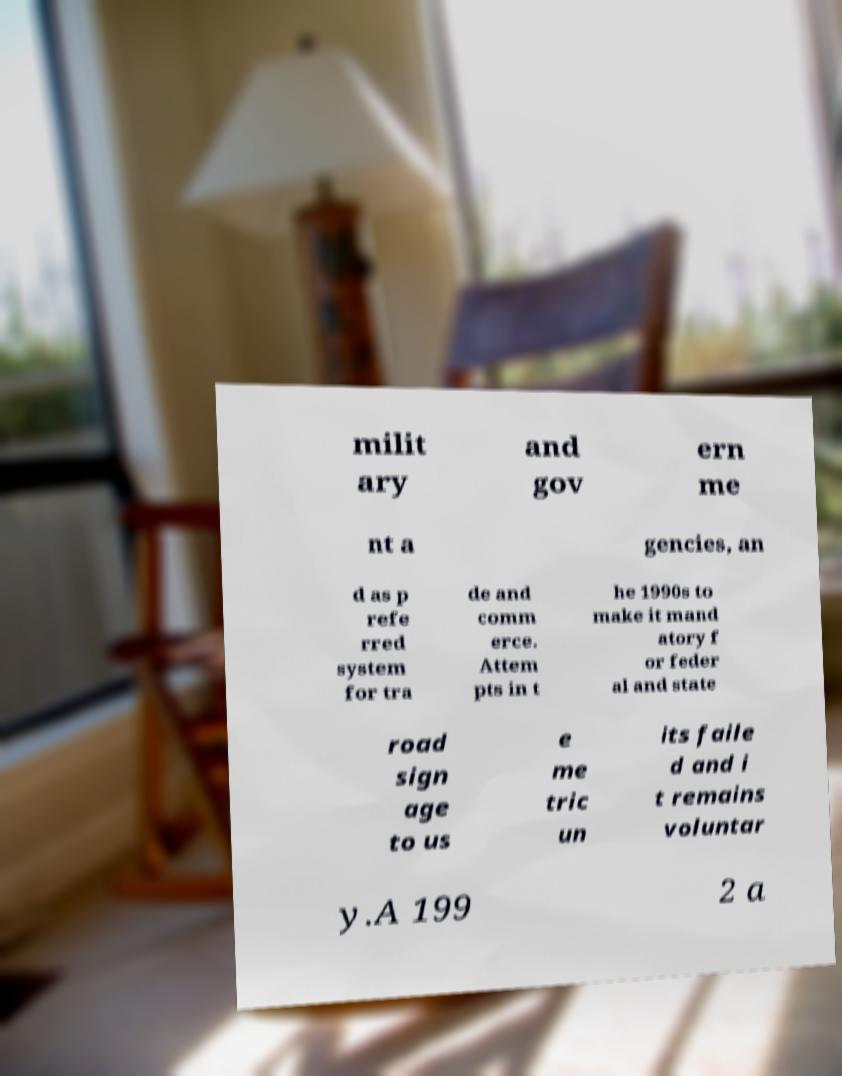Could you assist in decoding the text presented in this image and type it out clearly? milit ary and gov ern me nt a gencies, an d as p refe rred system for tra de and comm erce. Attem pts in t he 1990s to make it mand atory f or feder al and state road sign age to us e me tric un its faile d and i t remains voluntar y.A 199 2 a 